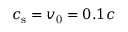Convert formula to latex. <formula><loc_0><loc_0><loc_500><loc_500>c _ { s } = v _ { 0 } = 0 . 1 c</formula> 